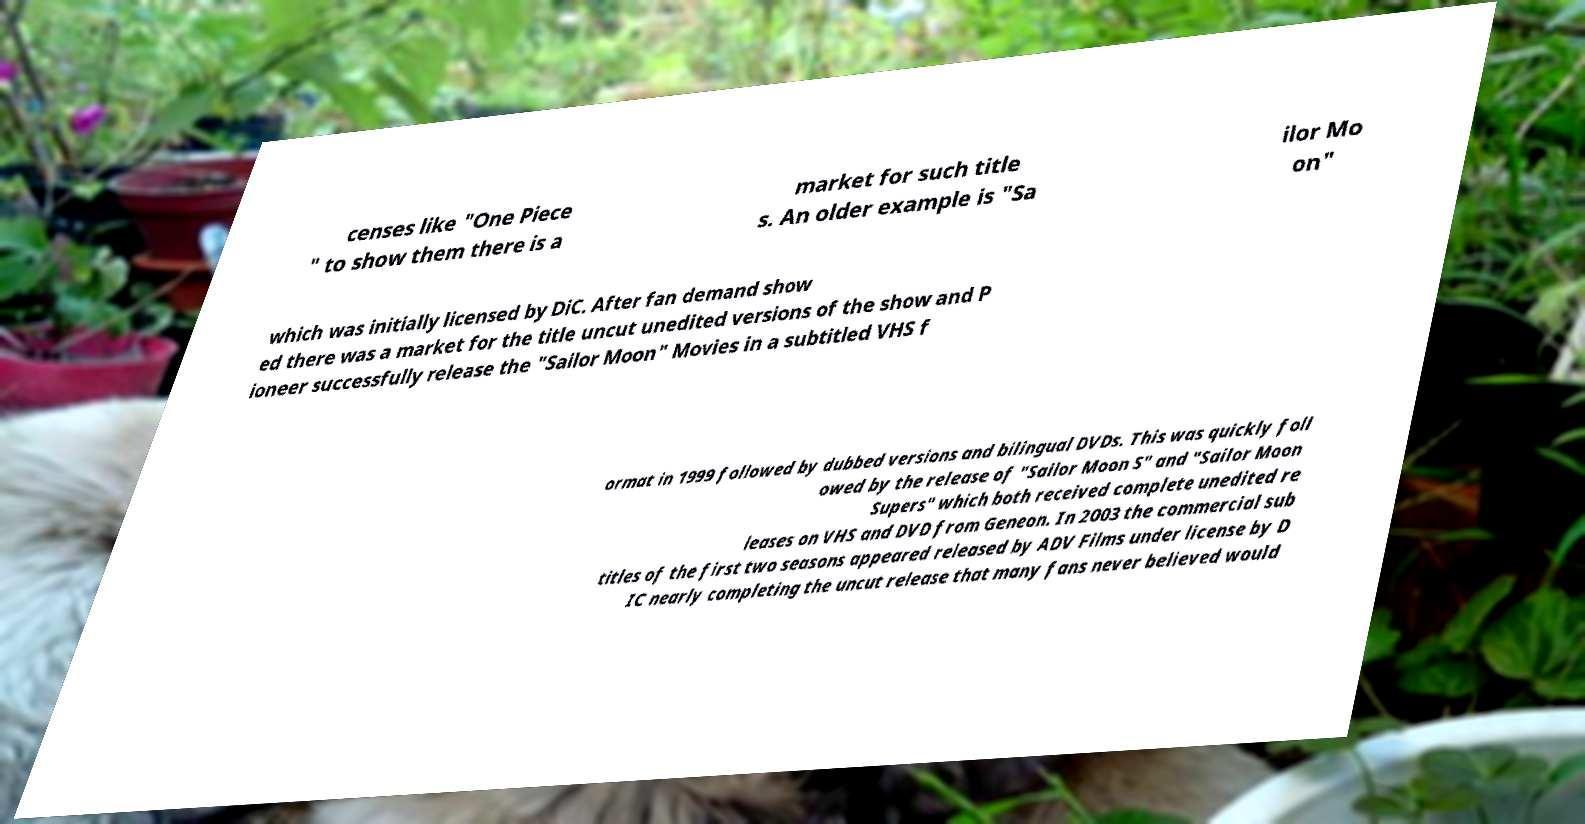Can you read and provide the text displayed in the image?This photo seems to have some interesting text. Can you extract and type it out for me? censes like "One Piece " to show them there is a market for such title s. An older example is "Sa ilor Mo on" which was initially licensed by DiC. After fan demand show ed there was a market for the title uncut unedited versions of the show and P ioneer successfully release the "Sailor Moon" Movies in a subtitled VHS f ormat in 1999 followed by dubbed versions and bilingual DVDs. This was quickly foll owed by the release of "Sailor Moon S" and "Sailor Moon Supers" which both received complete unedited re leases on VHS and DVD from Geneon. In 2003 the commercial sub titles of the first two seasons appeared released by ADV Films under license by D IC nearly completing the uncut release that many fans never believed would 